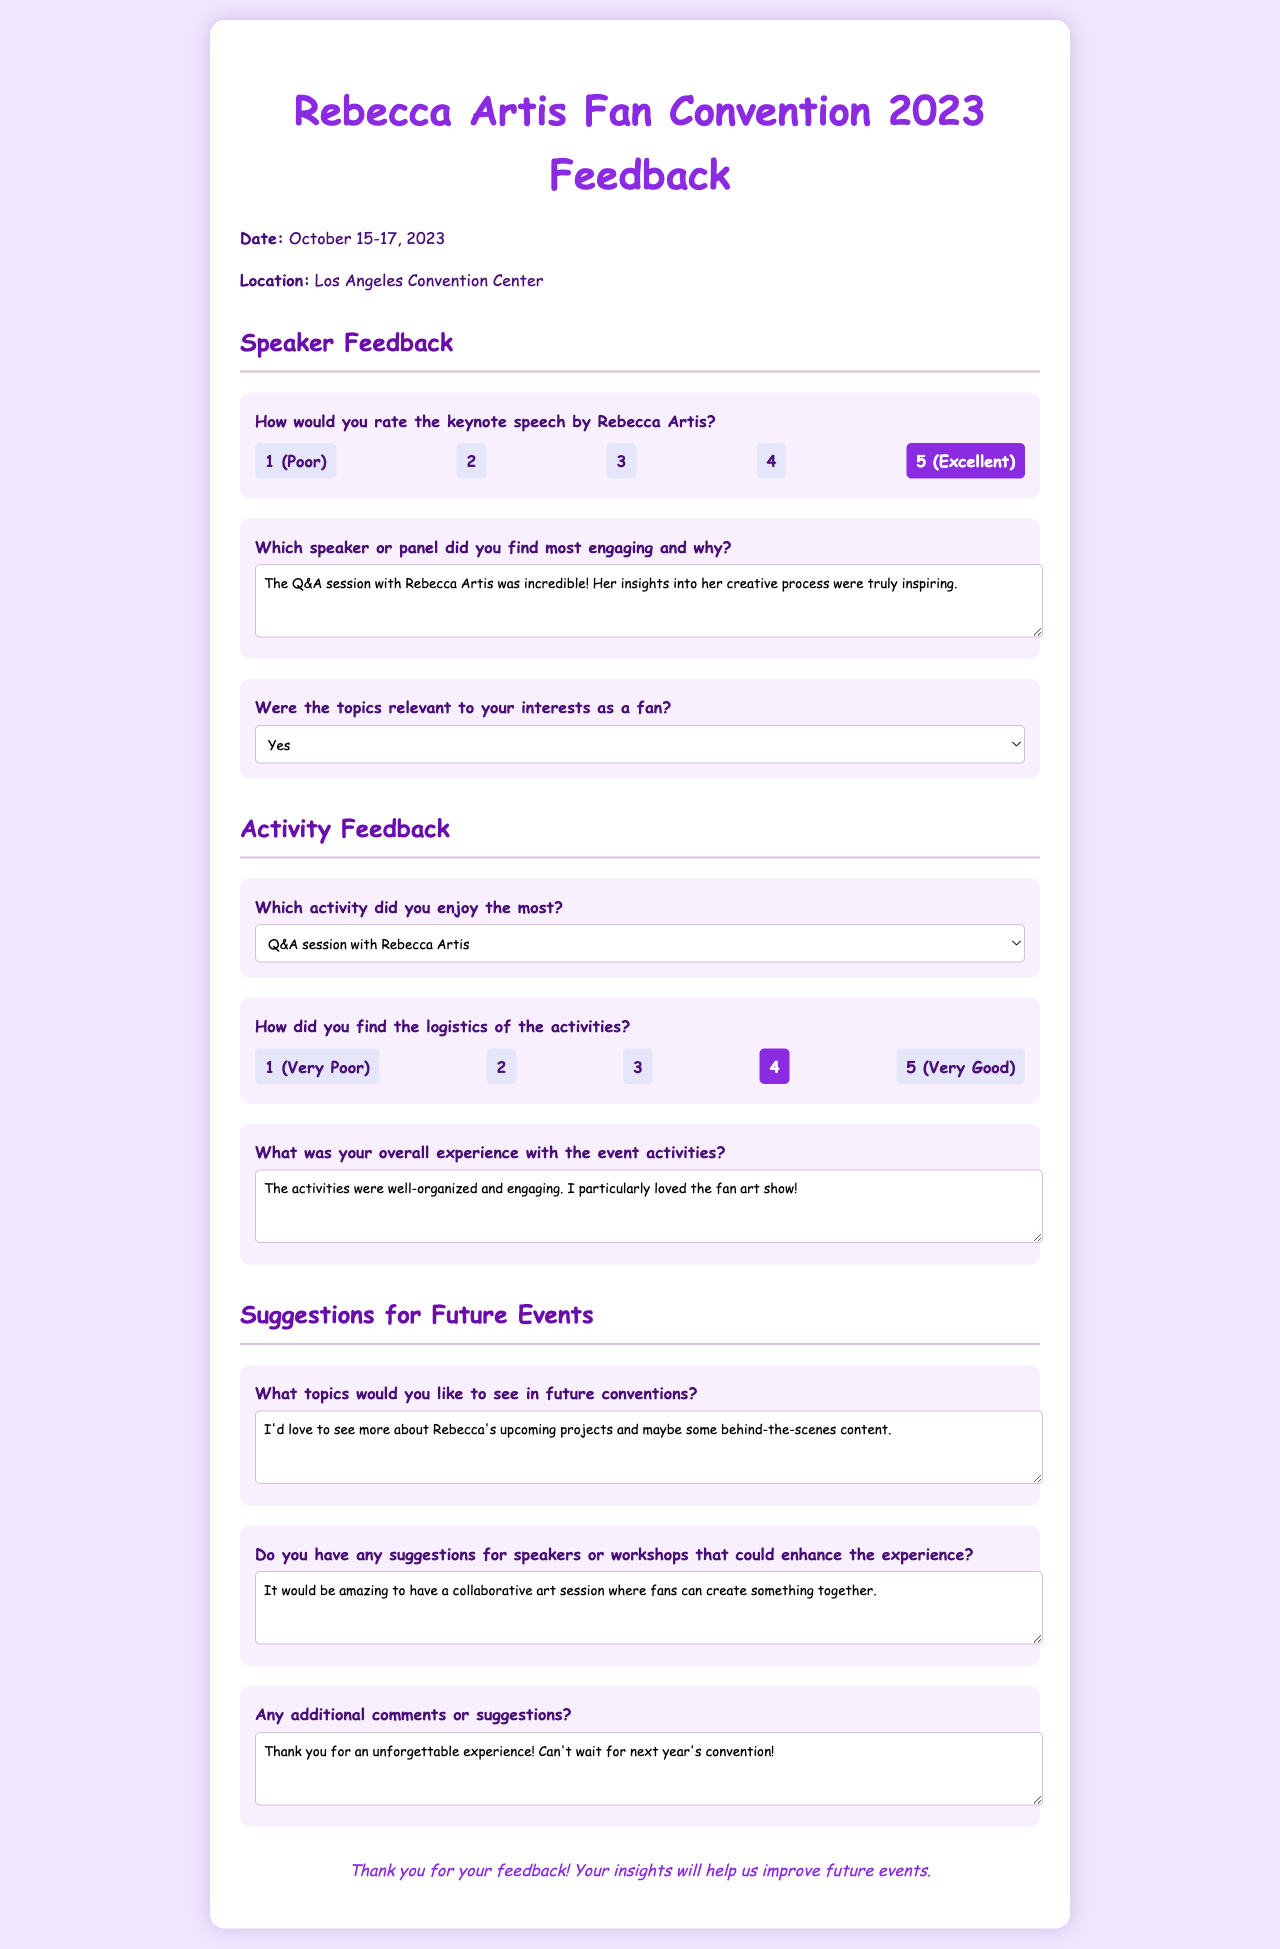What was the date of the convention? The date of the convention is explicitly mentioned in the document.
Answer: October 15-17, 2023 What was the location of the event? The document specifies the location where the convention took place.
Answer: Los Angeles Convention Center How did the attendee rate the keynote speech by Rebecca Artis? The document provides a rating scale for the keynote speech, which indicates the preference of the attendee.
Answer: 5 (Excellent) Which activity did the attendee enjoy the most? The document lists various activities, and the selected activity indicates the preference of the attendee.
Answer: Q&A session with Rebecca Artis What feedback did attendees provide about future topics? The document contains a specific section where attendees can suggest topics for future conventions.
Answer: More about Rebecca's upcoming projects and behind-the-scenes content How did the attendee rate the logistics of the activities? The document features a rating system, and the selected rating reveals the attendee's opinion on logistics.
Answer: 4 What was the overall experience of the attendee with the event activities? There is a section for general comments about the attendee's experience with the activities.
Answer: The activities were well-organized and engaging What suggestion did the attendee provide for speakers or workshops? The attendee's suggestions are captured in a dedicated section within the feedback form.
Answer: A collaborative art session where fans can create something together What additional comments did the attendee leave? The document includes a section for any extra thoughts, which reflects the attendee's overall sentiment.
Answer: Thank you for an unforgettable experience! Can't wait for next year's convention! 